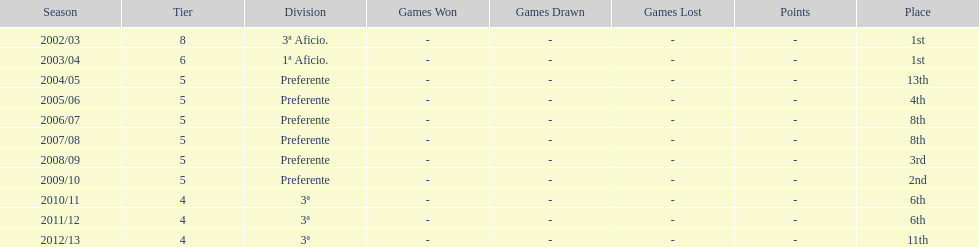How many times did internacional de madrid cf end the season at the top of their division? 2. 